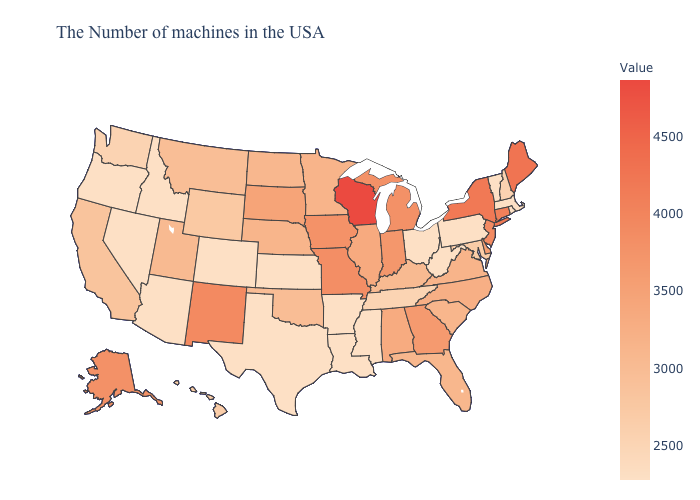Does the map have missing data?
Be succinct. No. Among the states that border California , which have the highest value?
Short answer required. Arizona, Nevada, Oregon. Among the states that border Massachusetts , does Rhode Island have the highest value?
Quick response, please. No. 